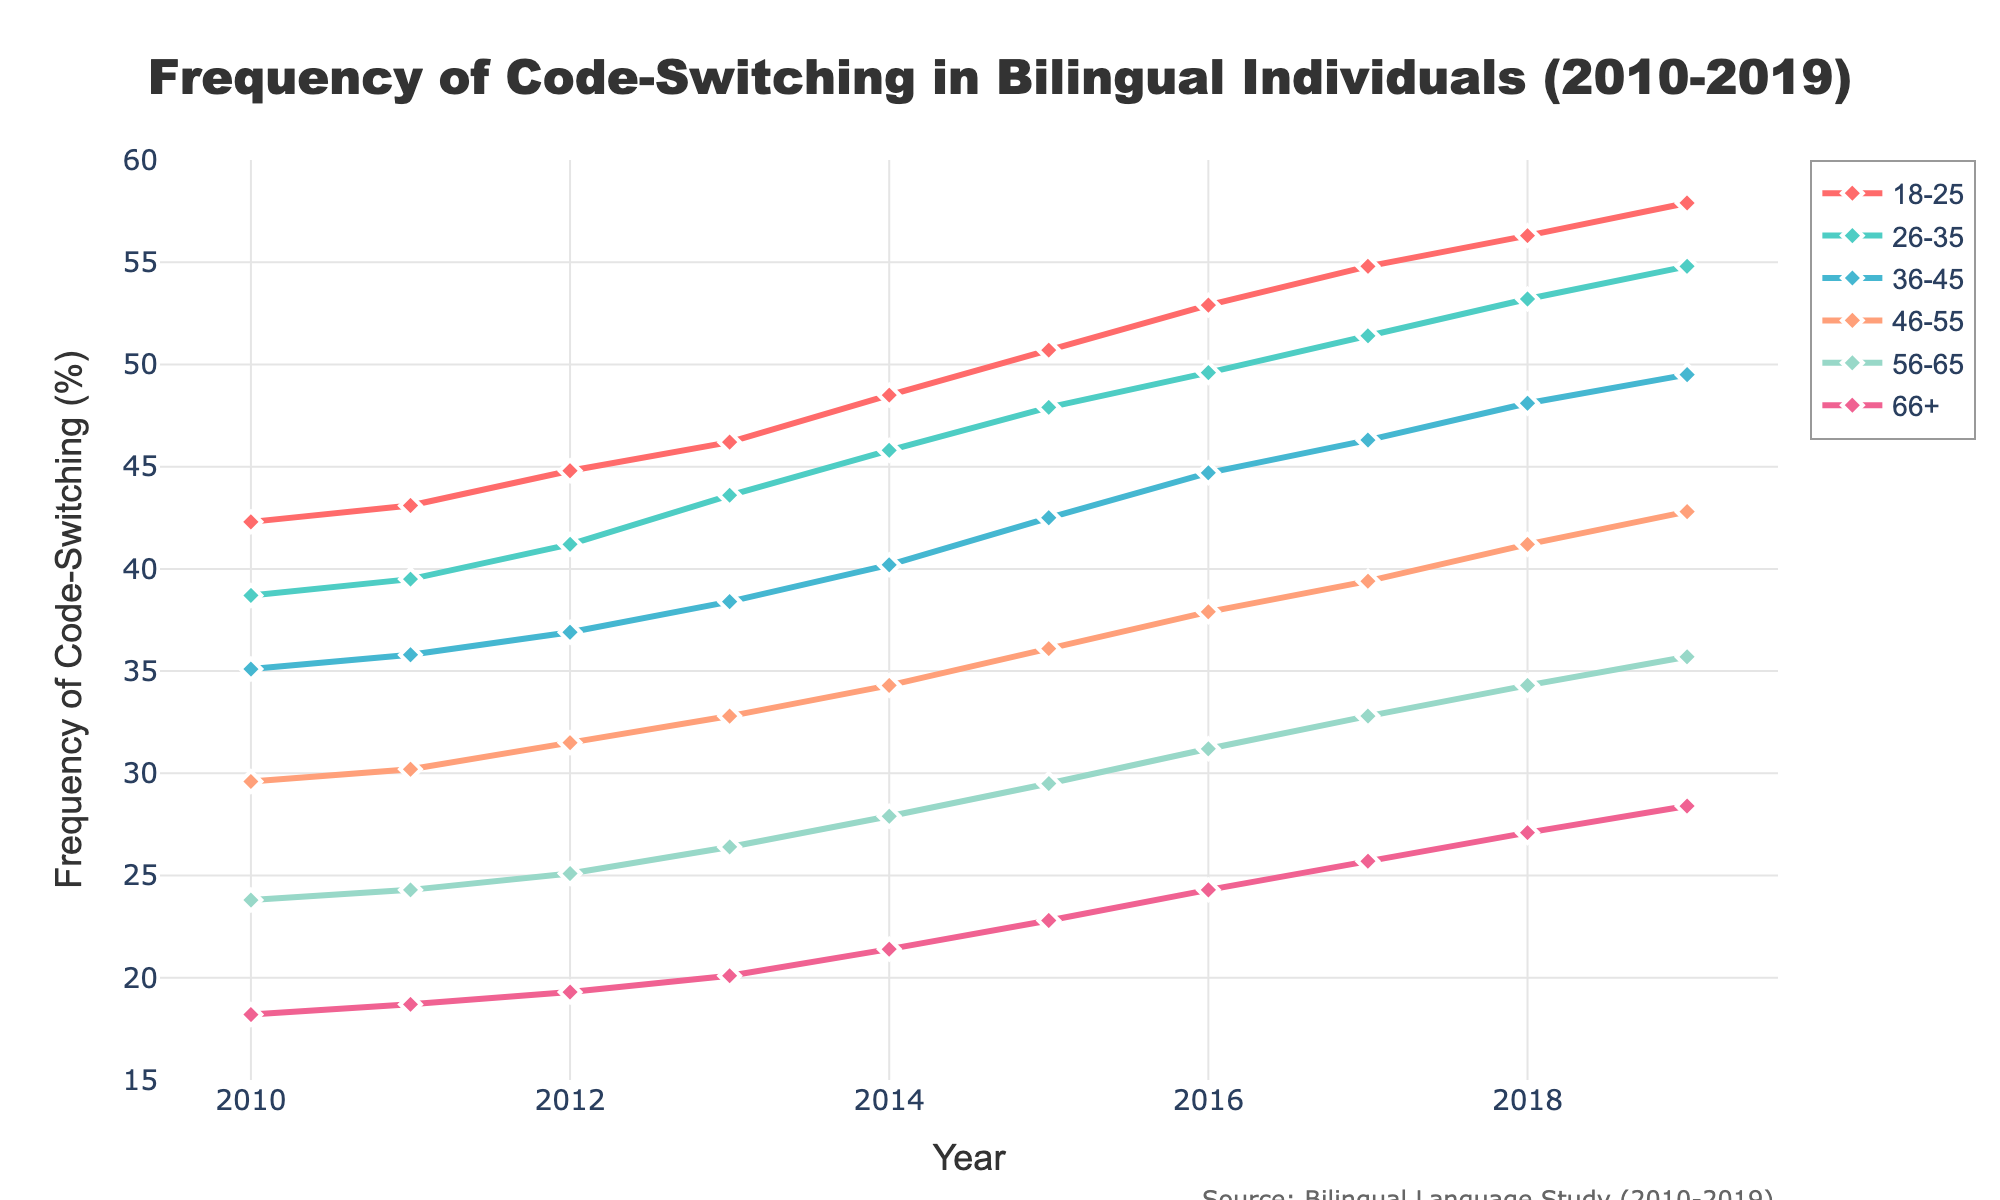What's the trend in the frequency of code-switching for the 18-25 age group? The line chart for the 18-25 age group shows a steady increase from 42.3% in 2010 to 57.9% in 2019. Each year, the frequency rises continuously without any dips.
Answer: Steady increase Which age group had the highest frequency of code-switching in 2019? By examining the endpoint of each line representing 2019, the 18-25 age group reaches the highest point at 57.9%.
Answer: 18-25 Between 2010 and 2019, which age group showed the largest absolute increase in frequency of code-switching? Calculating the difference between 2019 and 2010 for each group: 
  - 18-25: 57.9 - 42.3 = 15.6
  - 26-35: 54.8 - 38.7 = 16.1
  - 36-45: 49.5  - 35.1 = 14.4
  - 46-55: 42.8 - 29.6 = 13.2
  - 56-65: 35.7 - 23.8 = 11.9
  - 66+: 28.4 - 18.2 = 10.2
The 26-35 age group has the largest increase with 16.1%.
Answer: 26-35 Which age group has the slowest growth rate in code-switching frequency from 2010 to 2019? By comparing the slopes (difference/years) of each age group's line:
  - 18-25: (57.9 - 42.3) / 10 ≈ 1.56 per year
  - 26-35: (54.8 - 38.7) / 10 ≈ 1.61 per year
  - 36-45: (49.5 - 35.1) / 10 ≈ 1.44 per year
  - 46-55: (42.8 - 29.6) / 10 ≈ 1.32 per year
  - 56-65: (35.7 - 23.8) / 10 ≈ 1.19 per year
  - 66+: (28.4 - 18.2) / 10 ≈ 1.02 per year
The 66+ group has the slowest growth rate with about 1.02% per year.
Answer: 66+ In which years were there crossovers between any age group's line? No lines cross over each other in the chart from 2010 to 2019, as each group's frequency increases consistently without intersecting other groups.
Answer: No crossovers What is the difference in code-switching frequency between the 26-35 and 66+ age groups in 2015? Look at the data points for 2015:
  - 26-35: 47.9%
  - 66+: 22.8%
Difference: 47.9 - 22.8 = 25.1
Answer: 25.1 Which age group experienced the most noticeable change in frequency growth between 2014 and 2015? Comparing the differences for 2014 to 2015:
  - 18-25: 50.7 - 48.5 = 2.2
  - 26-35: 47.9 - 45.8 = 2.1
  - 36-45: 42.5 - 40.2 = 2.3
  - 46-55: 36.1 - 34.3 = 1.8
  - 56-65: 29.5 - 27.9 = 1.6
  - 66+: 22.8 - 21.4 = 1.4
The 36-45 age group had the most significant one-year change with an increase of 2.3.
Answer: 36-45 What can be inferred about the code-switching frequency trend among all age groups? Observing the general upward trend in lines for all age groups from 2010 to 2019 shows that all groups are experiencing an increase in code-switching frequency over the years.
Answer: Increasing for all 